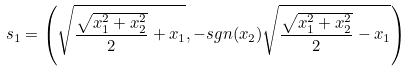<formula> <loc_0><loc_0><loc_500><loc_500>s _ { 1 } = \left ( \sqrt { \frac { \sqrt { x _ { 1 } ^ { 2 } + x _ { 2 } ^ { 2 } } } { 2 } + x _ { 1 } } , - s g n ( x _ { 2 } ) \sqrt { \frac { \sqrt { x _ { 1 } ^ { 2 } + x _ { 2 } ^ { 2 } } } { 2 } - x _ { 1 } } \right )</formula> 